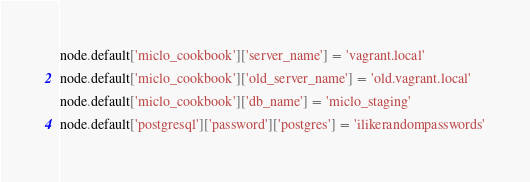<code> <loc_0><loc_0><loc_500><loc_500><_Ruby_>node.default['miclo_cookbook']['server_name'] = 'vagrant.local'
node.default['miclo_cookbook']['old_server_name'] = 'old.vagrant.local'
node.default['miclo_cookbook']['db_name'] = 'miclo_staging'
node.default['postgresql']['password']['postgres'] = 'ilikerandompasswords'
</code> 